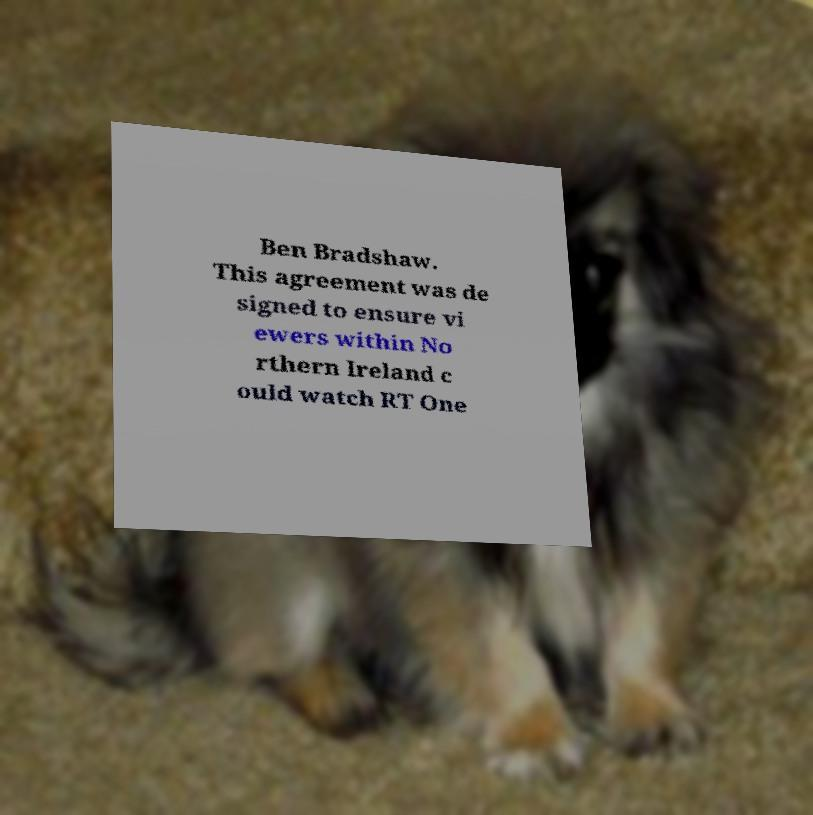Can you read and provide the text displayed in the image?This photo seems to have some interesting text. Can you extract and type it out for me? Ben Bradshaw. This agreement was de signed to ensure vi ewers within No rthern Ireland c ould watch RT One 